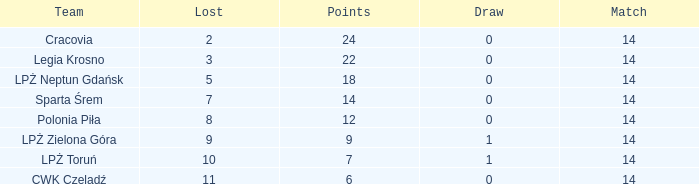What is the lowest points for a match before 14? None. 